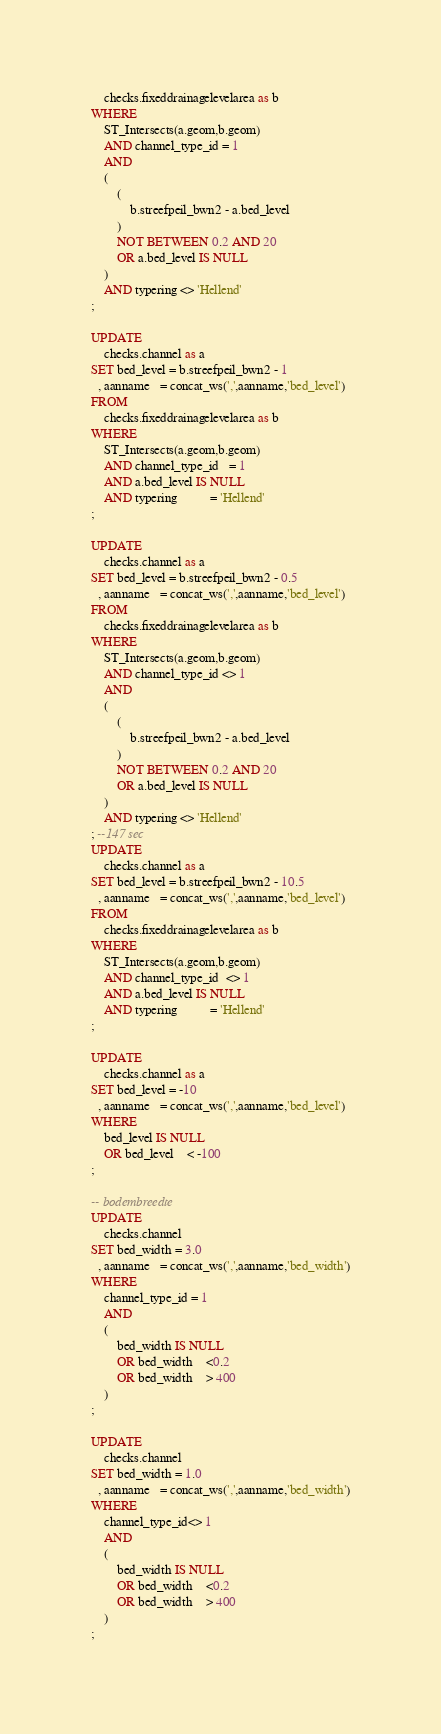<code> <loc_0><loc_0><loc_500><loc_500><_SQL_>    checks.fixeddrainagelevelarea as b
WHERE
    ST_Intersects(a.geom,b.geom)
    AND channel_type_id = 1
    AND
    (
        (
            b.streefpeil_bwn2 - a.bed_level
        )
        NOT BETWEEN 0.2 AND 20
        OR a.bed_level IS NULL
    )
    AND typering <> 'Hellend'
;

UPDATE
    checks.channel as a
SET bed_level = b.streefpeil_bwn2 - 1
  , aanname   = concat_ws(',',aanname,'bed_level')
FROM
    checks.fixeddrainagelevelarea as b
WHERE
    ST_Intersects(a.geom,b.geom)
    AND channel_type_id   = 1
    AND a.bed_level IS NULL
    AND typering          = 'Hellend'
;

UPDATE
    checks.channel as a
SET bed_level = b.streefpeil_bwn2 - 0.5
  , aanname   = concat_ws(',',aanname,'bed_level')
FROM
    checks.fixeddrainagelevelarea as b
WHERE
    ST_Intersects(a.geom,b.geom)
    AND channel_type_id <> 1
    AND
    (
        (
            b.streefpeil_bwn2 - a.bed_level
        )
        NOT BETWEEN 0.2 AND 20
        OR a.bed_level IS NULL
    )
    AND typering <> 'Hellend'
; --147 sec
UPDATE
    checks.channel as a
SET bed_level = b.streefpeil_bwn2 - 10.5
  , aanname   = concat_ws(',',aanname,'bed_level')
FROM
    checks.fixeddrainagelevelarea as b
WHERE
    ST_Intersects(a.geom,b.geom)
    AND channel_type_id  <> 1
    AND a.bed_level IS NULL
    AND typering          = 'Hellend'
;

UPDATE
    checks.channel as a
SET bed_level = -10
  , aanname   = concat_ws(',',aanname,'bed_level')
WHERE
    bed_level IS NULL
    OR bed_level    < -100
;

-- bodembreedte
UPDATE
    checks.channel
SET bed_width = 3.0
  , aanname   = concat_ws(',',aanname,'bed_width')
WHERE
    channel_type_id = 1
    AND
    (
        bed_width IS NULL
        OR bed_width    <0.2
        OR bed_width    > 400
    )
;

UPDATE
    checks.channel
SET bed_width = 1.0
  , aanname   = concat_ws(',',aanname,'bed_width')
WHERE
    channel_type_id<> 1
    AND
    (
        bed_width IS NULL
        OR bed_width    <0.2
        OR bed_width    > 400
    )
;</code> 